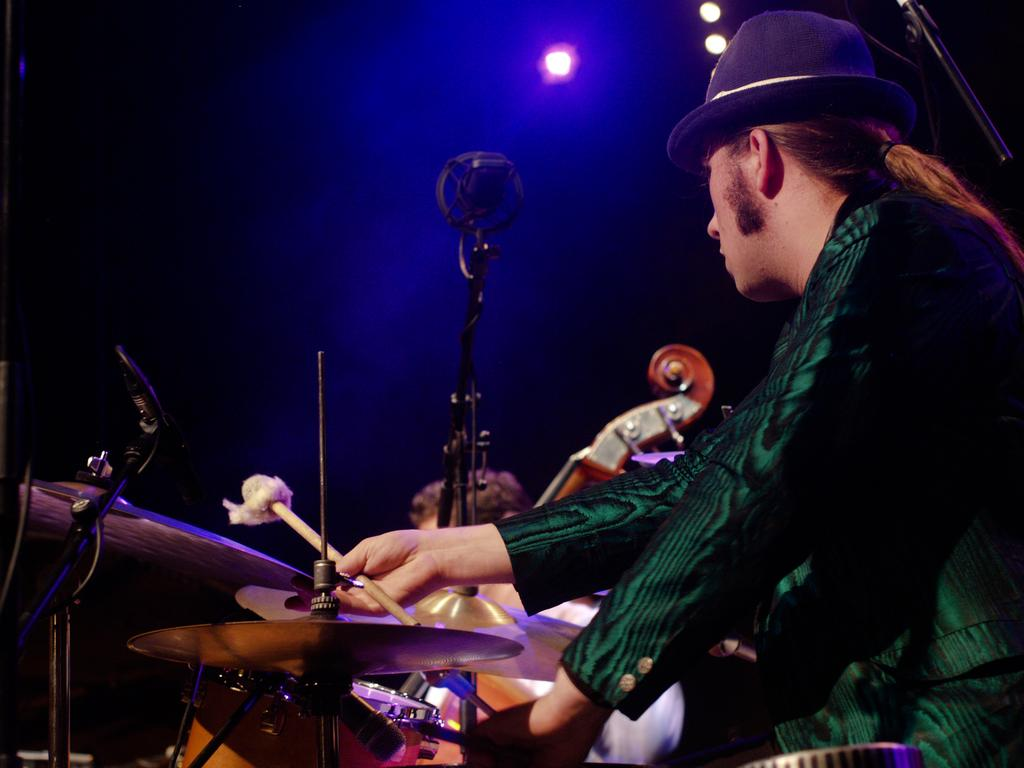Who is the person in the image? There is a man in the image. What is the man doing in the image? The man is seated and playing drums. What object is present in the image that is commonly used for amplifying sound? There is a microphone in the image. What type of yoke can be seen in the image? There is no yoke present in the image. How does the man's journey to the drum set affect the image? The image does not depict a journey or any movement, so it is not possible to determine how the man's journey might affect the image. 